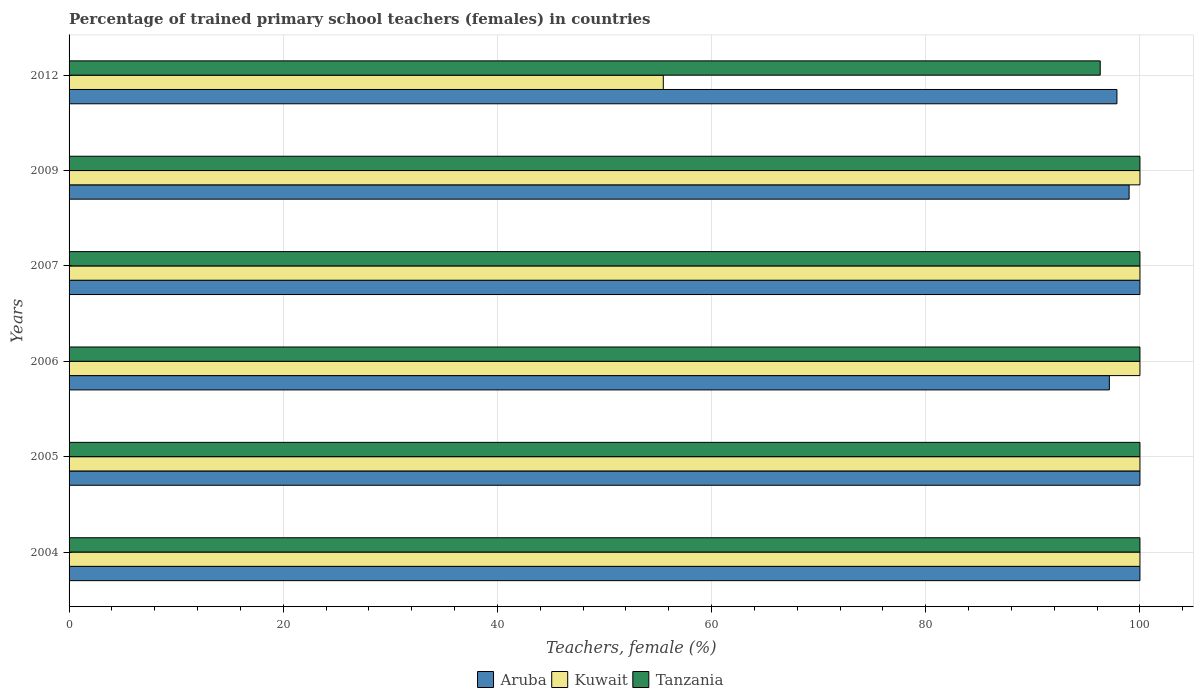How many different coloured bars are there?
Ensure brevity in your answer.  3. How many groups of bars are there?
Offer a very short reply. 6. Are the number of bars on each tick of the Y-axis equal?
Your answer should be very brief. Yes. How many bars are there on the 6th tick from the bottom?
Provide a short and direct response. 3. What is the label of the 3rd group of bars from the top?
Your response must be concise. 2007. Across all years, what is the maximum percentage of trained primary school teachers (females) in Kuwait?
Give a very brief answer. 100. Across all years, what is the minimum percentage of trained primary school teachers (females) in Aruba?
Offer a very short reply. 97.14. In which year was the percentage of trained primary school teachers (females) in Tanzania maximum?
Offer a terse response. 2004. What is the total percentage of trained primary school teachers (females) in Aruba in the graph?
Provide a succinct answer. 593.98. What is the difference between the percentage of trained primary school teachers (females) in Tanzania in 2005 and that in 2012?
Offer a very short reply. 3.71. What is the difference between the percentage of trained primary school teachers (females) in Tanzania in 2005 and the percentage of trained primary school teachers (females) in Kuwait in 2009?
Make the answer very short. 0. What is the average percentage of trained primary school teachers (females) in Kuwait per year?
Give a very brief answer. 92.58. What is the ratio of the percentage of trained primary school teachers (females) in Aruba in 2005 to that in 2012?
Your answer should be very brief. 1.02. What is the difference between the highest and the second highest percentage of trained primary school teachers (females) in Aruba?
Your response must be concise. 0. What is the difference between the highest and the lowest percentage of trained primary school teachers (females) in Aruba?
Provide a short and direct response. 2.86. In how many years, is the percentage of trained primary school teachers (females) in Tanzania greater than the average percentage of trained primary school teachers (females) in Tanzania taken over all years?
Your answer should be very brief. 5. Is the sum of the percentage of trained primary school teachers (females) in Kuwait in 2004 and 2012 greater than the maximum percentage of trained primary school teachers (females) in Aruba across all years?
Ensure brevity in your answer.  Yes. What does the 1st bar from the top in 2005 represents?
Ensure brevity in your answer.  Tanzania. What does the 3rd bar from the bottom in 2007 represents?
Your answer should be compact. Tanzania. Does the graph contain grids?
Ensure brevity in your answer.  Yes. How many legend labels are there?
Make the answer very short. 3. How are the legend labels stacked?
Your response must be concise. Horizontal. What is the title of the graph?
Ensure brevity in your answer.  Percentage of trained primary school teachers (females) in countries. Does "Tanzania" appear as one of the legend labels in the graph?
Make the answer very short. Yes. What is the label or title of the X-axis?
Your response must be concise. Teachers, female (%). What is the Teachers, female (%) in Aruba in 2004?
Offer a very short reply. 100. What is the Teachers, female (%) in Tanzania in 2004?
Your answer should be compact. 100. What is the Teachers, female (%) of Aruba in 2005?
Ensure brevity in your answer.  100. What is the Teachers, female (%) of Kuwait in 2005?
Offer a terse response. 100. What is the Teachers, female (%) in Aruba in 2006?
Offer a terse response. 97.14. What is the Teachers, female (%) in Tanzania in 2006?
Give a very brief answer. 100. What is the Teachers, female (%) in Aruba in 2007?
Provide a succinct answer. 100. What is the Teachers, female (%) of Kuwait in 2007?
Provide a succinct answer. 100. What is the Teachers, female (%) in Tanzania in 2007?
Provide a succinct answer. 100. What is the Teachers, female (%) in Aruba in 2009?
Offer a terse response. 98.99. What is the Teachers, female (%) of Tanzania in 2009?
Keep it short and to the point. 100. What is the Teachers, female (%) in Aruba in 2012?
Your answer should be compact. 97.85. What is the Teachers, female (%) in Kuwait in 2012?
Your response must be concise. 55.49. What is the Teachers, female (%) in Tanzania in 2012?
Give a very brief answer. 96.29. Across all years, what is the maximum Teachers, female (%) in Aruba?
Your answer should be compact. 100. Across all years, what is the minimum Teachers, female (%) of Aruba?
Make the answer very short. 97.14. Across all years, what is the minimum Teachers, female (%) in Kuwait?
Provide a succinct answer. 55.49. Across all years, what is the minimum Teachers, female (%) of Tanzania?
Your answer should be very brief. 96.29. What is the total Teachers, female (%) of Aruba in the graph?
Your response must be concise. 593.98. What is the total Teachers, female (%) of Kuwait in the graph?
Provide a succinct answer. 555.49. What is the total Teachers, female (%) of Tanzania in the graph?
Offer a very short reply. 596.29. What is the difference between the Teachers, female (%) of Aruba in 2004 and that in 2006?
Provide a short and direct response. 2.86. What is the difference between the Teachers, female (%) of Tanzania in 2004 and that in 2006?
Offer a very short reply. 0. What is the difference between the Teachers, female (%) in Kuwait in 2004 and that in 2007?
Make the answer very short. 0. What is the difference between the Teachers, female (%) in Aruba in 2004 and that in 2012?
Your answer should be very brief. 2.15. What is the difference between the Teachers, female (%) in Kuwait in 2004 and that in 2012?
Offer a terse response. 44.51. What is the difference between the Teachers, female (%) in Tanzania in 2004 and that in 2012?
Provide a succinct answer. 3.71. What is the difference between the Teachers, female (%) of Aruba in 2005 and that in 2006?
Provide a short and direct response. 2.86. What is the difference between the Teachers, female (%) of Tanzania in 2005 and that in 2006?
Make the answer very short. 0. What is the difference between the Teachers, female (%) of Aruba in 2005 and that in 2007?
Give a very brief answer. 0. What is the difference between the Teachers, female (%) in Aruba in 2005 and that in 2009?
Offer a very short reply. 1.01. What is the difference between the Teachers, female (%) in Kuwait in 2005 and that in 2009?
Ensure brevity in your answer.  0. What is the difference between the Teachers, female (%) in Aruba in 2005 and that in 2012?
Ensure brevity in your answer.  2.15. What is the difference between the Teachers, female (%) of Kuwait in 2005 and that in 2012?
Make the answer very short. 44.51. What is the difference between the Teachers, female (%) of Tanzania in 2005 and that in 2012?
Keep it short and to the point. 3.71. What is the difference between the Teachers, female (%) of Aruba in 2006 and that in 2007?
Keep it short and to the point. -2.86. What is the difference between the Teachers, female (%) of Tanzania in 2006 and that in 2007?
Give a very brief answer. 0. What is the difference between the Teachers, female (%) in Aruba in 2006 and that in 2009?
Your answer should be very brief. -1.85. What is the difference between the Teachers, female (%) of Kuwait in 2006 and that in 2009?
Give a very brief answer. 0. What is the difference between the Teachers, female (%) of Tanzania in 2006 and that in 2009?
Provide a succinct answer. 0. What is the difference between the Teachers, female (%) in Aruba in 2006 and that in 2012?
Your answer should be very brief. -0.71. What is the difference between the Teachers, female (%) of Kuwait in 2006 and that in 2012?
Keep it short and to the point. 44.51. What is the difference between the Teachers, female (%) in Tanzania in 2006 and that in 2012?
Keep it short and to the point. 3.71. What is the difference between the Teachers, female (%) of Aruba in 2007 and that in 2009?
Your answer should be very brief. 1.01. What is the difference between the Teachers, female (%) in Tanzania in 2007 and that in 2009?
Provide a short and direct response. 0. What is the difference between the Teachers, female (%) in Aruba in 2007 and that in 2012?
Offer a terse response. 2.15. What is the difference between the Teachers, female (%) of Kuwait in 2007 and that in 2012?
Ensure brevity in your answer.  44.51. What is the difference between the Teachers, female (%) of Tanzania in 2007 and that in 2012?
Give a very brief answer. 3.71. What is the difference between the Teachers, female (%) of Aruba in 2009 and that in 2012?
Ensure brevity in your answer.  1.14. What is the difference between the Teachers, female (%) in Kuwait in 2009 and that in 2012?
Offer a terse response. 44.51. What is the difference between the Teachers, female (%) in Tanzania in 2009 and that in 2012?
Provide a short and direct response. 3.71. What is the difference between the Teachers, female (%) of Aruba in 2004 and the Teachers, female (%) of Kuwait in 2005?
Offer a terse response. 0. What is the difference between the Teachers, female (%) of Aruba in 2004 and the Teachers, female (%) of Kuwait in 2006?
Offer a terse response. 0. What is the difference between the Teachers, female (%) in Aruba in 2004 and the Teachers, female (%) in Kuwait in 2007?
Offer a terse response. 0. What is the difference between the Teachers, female (%) in Aruba in 2004 and the Teachers, female (%) in Tanzania in 2007?
Give a very brief answer. 0. What is the difference between the Teachers, female (%) of Aruba in 2004 and the Teachers, female (%) of Kuwait in 2009?
Offer a terse response. 0. What is the difference between the Teachers, female (%) in Aruba in 2004 and the Teachers, female (%) in Tanzania in 2009?
Your answer should be compact. 0. What is the difference between the Teachers, female (%) in Aruba in 2004 and the Teachers, female (%) in Kuwait in 2012?
Keep it short and to the point. 44.51. What is the difference between the Teachers, female (%) of Aruba in 2004 and the Teachers, female (%) of Tanzania in 2012?
Make the answer very short. 3.71. What is the difference between the Teachers, female (%) in Kuwait in 2004 and the Teachers, female (%) in Tanzania in 2012?
Provide a short and direct response. 3.71. What is the difference between the Teachers, female (%) of Aruba in 2005 and the Teachers, female (%) of Tanzania in 2006?
Your response must be concise. 0. What is the difference between the Teachers, female (%) in Kuwait in 2005 and the Teachers, female (%) in Tanzania in 2006?
Provide a succinct answer. 0. What is the difference between the Teachers, female (%) of Aruba in 2005 and the Teachers, female (%) of Tanzania in 2009?
Provide a short and direct response. 0. What is the difference between the Teachers, female (%) of Aruba in 2005 and the Teachers, female (%) of Kuwait in 2012?
Keep it short and to the point. 44.51. What is the difference between the Teachers, female (%) of Aruba in 2005 and the Teachers, female (%) of Tanzania in 2012?
Your answer should be very brief. 3.71. What is the difference between the Teachers, female (%) in Kuwait in 2005 and the Teachers, female (%) in Tanzania in 2012?
Make the answer very short. 3.71. What is the difference between the Teachers, female (%) of Aruba in 2006 and the Teachers, female (%) of Kuwait in 2007?
Keep it short and to the point. -2.86. What is the difference between the Teachers, female (%) in Aruba in 2006 and the Teachers, female (%) in Tanzania in 2007?
Your answer should be compact. -2.86. What is the difference between the Teachers, female (%) of Aruba in 2006 and the Teachers, female (%) of Kuwait in 2009?
Your answer should be very brief. -2.86. What is the difference between the Teachers, female (%) in Aruba in 2006 and the Teachers, female (%) in Tanzania in 2009?
Your response must be concise. -2.86. What is the difference between the Teachers, female (%) of Aruba in 2006 and the Teachers, female (%) of Kuwait in 2012?
Keep it short and to the point. 41.65. What is the difference between the Teachers, female (%) of Aruba in 2006 and the Teachers, female (%) of Tanzania in 2012?
Ensure brevity in your answer.  0.85. What is the difference between the Teachers, female (%) in Kuwait in 2006 and the Teachers, female (%) in Tanzania in 2012?
Your answer should be compact. 3.71. What is the difference between the Teachers, female (%) in Aruba in 2007 and the Teachers, female (%) in Kuwait in 2009?
Give a very brief answer. 0. What is the difference between the Teachers, female (%) in Kuwait in 2007 and the Teachers, female (%) in Tanzania in 2009?
Make the answer very short. 0. What is the difference between the Teachers, female (%) in Aruba in 2007 and the Teachers, female (%) in Kuwait in 2012?
Give a very brief answer. 44.51. What is the difference between the Teachers, female (%) in Aruba in 2007 and the Teachers, female (%) in Tanzania in 2012?
Give a very brief answer. 3.71. What is the difference between the Teachers, female (%) in Kuwait in 2007 and the Teachers, female (%) in Tanzania in 2012?
Your answer should be very brief. 3.71. What is the difference between the Teachers, female (%) in Aruba in 2009 and the Teachers, female (%) in Kuwait in 2012?
Ensure brevity in your answer.  43.5. What is the difference between the Teachers, female (%) in Aruba in 2009 and the Teachers, female (%) in Tanzania in 2012?
Give a very brief answer. 2.7. What is the difference between the Teachers, female (%) in Kuwait in 2009 and the Teachers, female (%) in Tanzania in 2012?
Keep it short and to the point. 3.71. What is the average Teachers, female (%) of Aruba per year?
Your answer should be very brief. 99. What is the average Teachers, female (%) in Kuwait per year?
Provide a succinct answer. 92.58. What is the average Teachers, female (%) of Tanzania per year?
Your response must be concise. 99.38. In the year 2004, what is the difference between the Teachers, female (%) of Aruba and Teachers, female (%) of Kuwait?
Offer a very short reply. 0. In the year 2004, what is the difference between the Teachers, female (%) in Aruba and Teachers, female (%) in Tanzania?
Make the answer very short. 0. In the year 2004, what is the difference between the Teachers, female (%) in Kuwait and Teachers, female (%) in Tanzania?
Make the answer very short. 0. In the year 2005, what is the difference between the Teachers, female (%) of Aruba and Teachers, female (%) of Kuwait?
Your response must be concise. 0. In the year 2005, what is the difference between the Teachers, female (%) of Aruba and Teachers, female (%) of Tanzania?
Keep it short and to the point. 0. In the year 2006, what is the difference between the Teachers, female (%) of Aruba and Teachers, female (%) of Kuwait?
Keep it short and to the point. -2.86. In the year 2006, what is the difference between the Teachers, female (%) of Aruba and Teachers, female (%) of Tanzania?
Give a very brief answer. -2.86. In the year 2006, what is the difference between the Teachers, female (%) of Kuwait and Teachers, female (%) of Tanzania?
Give a very brief answer. 0. In the year 2007, what is the difference between the Teachers, female (%) of Kuwait and Teachers, female (%) of Tanzania?
Make the answer very short. 0. In the year 2009, what is the difference between the Teachers, female (%) of Aruba and Teachers, female (%) of Kuwait?
Provide a short and direct response. -1.01. In the year 2009, what is the difference between the Teachers, female (%) in Aruba and Teachers, female (%) in Tanzania?
Your response must be concise. -1.01. In the year 2009, what is the difference between the Teachers, female (%) of Kuwait and Teachers, female (%) of Tanzania?
Provide a succinct answer. 0. In the year 2012, what is the difference between the Teachers, female (%) in Aruba and Teachers, female (%) in Kuwait?
Provide a short and direct response. 42.36. In the year 2012, what is the difference between the Teachers, female (%) in Aruba and Teachers, female (%) in Tanzania?
Your response must be concise. 1.56. In the year 2012, what is the difference between the Teachers, female (%) of Kuwait and Teachers, female (%) of Tanzania?
Keep it short and to the point. -40.8. What is the ratio of the Teachers, female (%) of Aruba in 2004 to that in 2005?
Your answer should be compact. 1. What is the ratio of the Teachers, female (%) in Aruba in 2004 to that in 2006?
Provide a succinct answer. 1.03. What is the ratio of the Teachers, female (%) of Tanzania in 2004 to that in 2006?
Offer a terse response. 1. What is the ratio of the Teachers, female (%) in Aruba in 2004 to that in 2007?
Keep it short and to the point. 1. What is the ratio of the Teachers, female (%) in Aruba in 2004 to that in 2009?
Ensure brevity in your answer.  1.01. What is the ratio of the Teachers, female (%) in Tanzania in 2004 to that in 2009?
Give a very brief answer. 1. What is the ratio of the Teachers, female (%) in Aruba in 2004 to that in 2012?
Give a very brief answer. 1.02. What is the ratio of the Teachers, female (%) of Kuwait in 2004 to that in 2012?
Give a very brief answer. 1.8. What is the ratio of the Teachers, female (%) of Aruba in 2005 to that in 2006?
Keep it short and to the point. 1.03. What is the ratio of the Teachers, female (%) of Kuwait in 2005 to that in 2006?
Your answer should be compact. 1. What is the ratio of the Teachers, female (%) of Aruba in 2005 to that in 2007?
Give a very brief answer. 1. What is the ratio of the Teachers, female (%) of Aruba in 2005 to that in 2009?
Your answer should be very brief. 1.01. What is the ratio of the Teachers, female (%) in Tanzania in 2005 to that in 2009?
Keep it short and to the point. 1. What is the ratio of the Teachers, female (%) in Aruba in 2005 to that in 2012?
Provide a short and direct response. 1.02. What is the ratio of the Teachers, female (%) in Kuwait in 2005 to that in 2012?
Your answer should be compact. 1.8. What is the ratio of the Teachers, female (%) in Aruba in 2006 to that in 2007?
Offer a very short reply. 0.97. What is the ratio of the Teachers, female (%) of Tanzania in 2006 to that in 2007?
Ensure brevity in your answer.  1. What is the ratio of the Teachers, female (%) in Aruba in 2006 to that in 2009?
Make the answer very short. 0.98. What is the ratio of the Teachers, female (%) of Kuwait in 2006 to that in 2009?
Offer a terse response. 1. What is the ratio of the Teachers, female (%) of Tanzania in 2006 to that in 2009?
Offer a very short reply. 1. What is the ratio of the Teachers, female (%) of Kuwait in 2006 to that in 2012?
Give a very brief answer. 1.8. What is the ratio of the Teachers, female (%) of Tanzania in 2006 to that in 2012?
Make the answer very short. 1.04. What is the ratio of the Teachers, female (%) in Aruba in 2007 to that in 2009?
Provide a succinct answer. 1.01. What is the ratio of the Teachers, female (%) in Kuwait in 2007 to that in 2009?
Make the answer very short. 1. What is the ratio of the Teachers, female (%) of Aruba in 2007 to that in 2012?
Your response must be concise. 1.02. What is the ratio of the Teachers, female (%) of Kuwait in 2007 to that in 2012?
Give a very brief answer. 1.8. What is the ratio of the Teachers, female (%) of Aruba in 2009 to that in 2012?
Your answer should be compact. 1.01. What is the ratio of the Teachers, female (%) in Kuwait in 2009 to that in 2012?
Provide a succinct answer. 1.8. What is the ratio of the Teachers, female (%) in Tanzania in 2009 to that in 2012?
Your answer should be compact. 1.04. What is the difference between the highest and the second highest Teachers, female (%) in Tanzania?
Provide a succinct answer. 0. What is the difference between the highest and the lowest Teachers, female (%) of Aruba?
Make the answer very short. 2.86. What is the difference between the highest and the lowest Teachers, female (%) of Kuwait?
Ensure brevity in your answer.  44.51. What is the difference between the highest and the lowest Teachers, female (%) in Tanzania?
Provide a succinct answer. 3.71. 